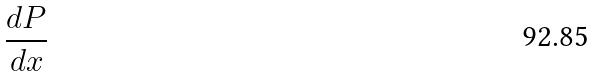<formula> <loc_0><loc_0><loc_500><loc_500>\frac { d P } { d x }</formula> 